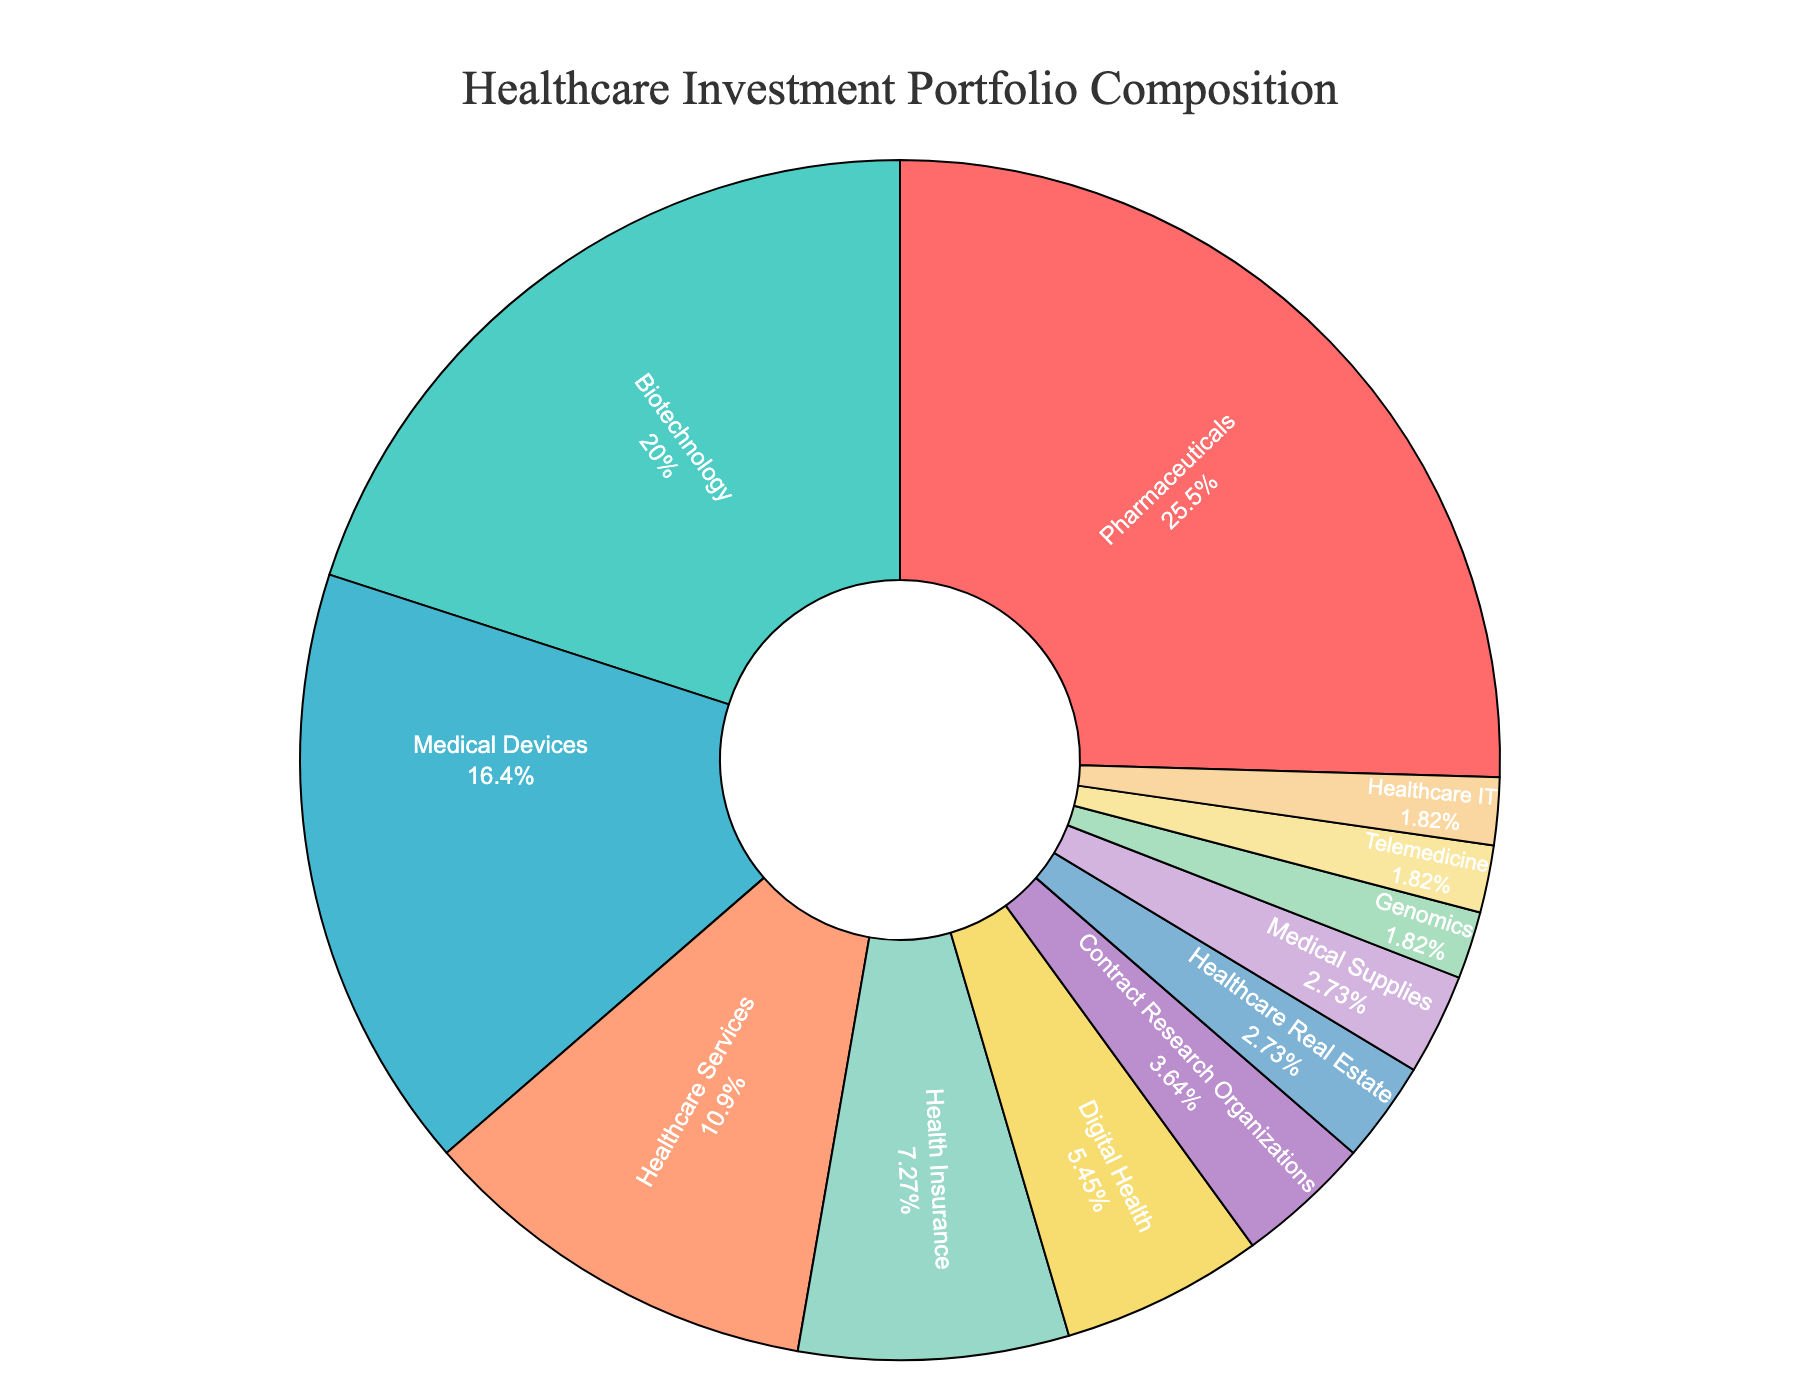What's the combined percentage of investment in Medical Devices, Digital Health, and Genomics sectors? To find the combined percentage, sum the individual percentages of Medical Devices, Digital Health, and Genomics: 18% + 6% + 2% = 26%
Answer: 26% Which sector has the largest investment percentage, and what is it? The sector with the largest segment in the pie chart represents the highest percentage. The Pharmaceuticals sector has the largest investment percentage of 28%.
Answer: Pharmaceuticals, 28% How does the investment in Biotechnology compare to the investment in Contract Research Organizations? The pie chart shows that Biotechnology has a larger percentage of 22%, whereas Contract Research Organizations have a smaller percentage of 4%. Therefore, Biotechnology has a higher investment compared to Contract Research Organizations.
Answer: Biotechnology has a higher investment By how much does the investment in Health Insurance exceed the investment in Telemedicine? The percentage for Health Insurance is 8%, and for Telemedicine, it is 2%. The difference is 8% - 2% = 6%.
Answer: 6% Among the sectors with less than 5% investment, which one has the highest percentage? The sectors with less than 5% investment include Contract Research Organizations (4%), Healthcare Real Estate (3%), Medical Supplies (3%), Genomics (2%), Telemedicine (2%), and Healthcare IT (2%). Among these, Contract Research Organizations have the highest percentage at 4%.
Answer: Contract Research Organizations What is the average percentage of investment across all sectors? To find the average, sum all percentages and divide by the number of sectors. Sum: 28 + 22 + 18 + 12 + 8 + 6 + 4 + 3 + 3 + 2 + 2 + 2 = 110. Number of sectors: 12. Average: 110/12 ≈ 9.17%.
Answer: 9.17% What color represents the Digital Health sector in the chart? The Digital Health sector is marked with a specific color in the chart. Referring to the given custom palette, Digital Health is represented by the color corresponding to its segment in the pie chart.
Answer: Light Yellow Which sectors combined account for over 50% of the investment? Starting from the largest percentages and adding them until the sum exceeds 50%. Pharmaceuticals: 28%, plus Biotechnology: 22%, sums to 50%. These two sectors combined account for just exactly 50%.
Answer: Pharmaceuticals and Biotechnology How many sectors have an investment percentage of 2%? The pie chart shows three sectors with exactly 2% each: Genomics, Telemedicine, and Healthcare IT.
Answer: 3 